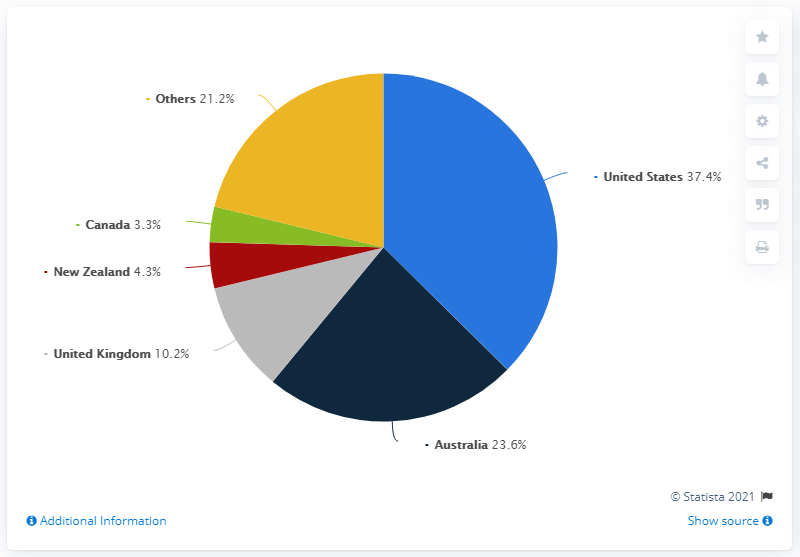List a handful of essential elements in this visual. In 2019, approximately 37.4% of BEC scams were detected in the United States. The United States was 37.4% of the targeted countries by BEC scams. The sum total of Canada and other countries' targeted rates by BEC scams is 24.5. 